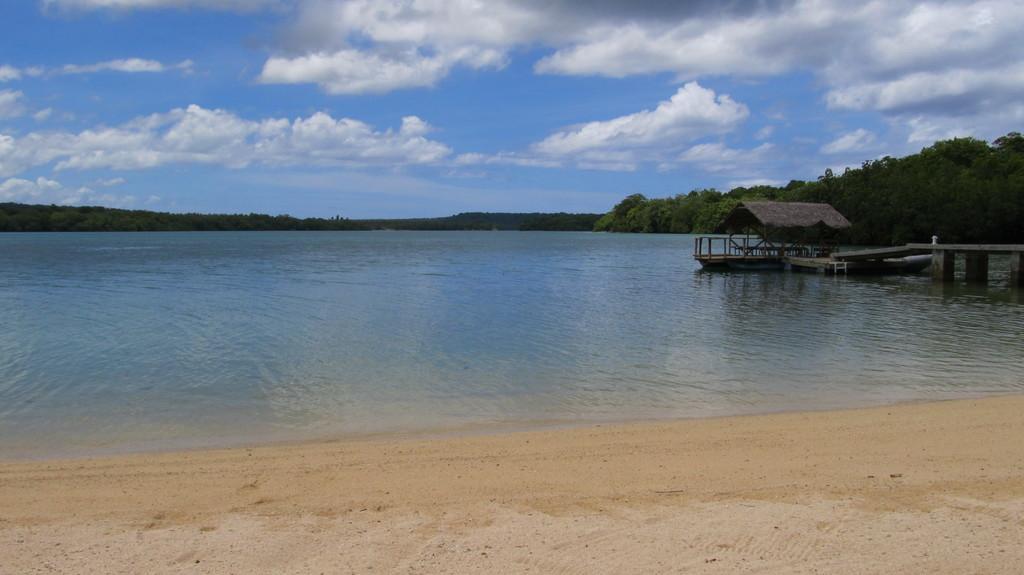Please provide a concise description of this image. In this picture I can see trees and water and a wooden bridge and a blue cloudy Sky. 